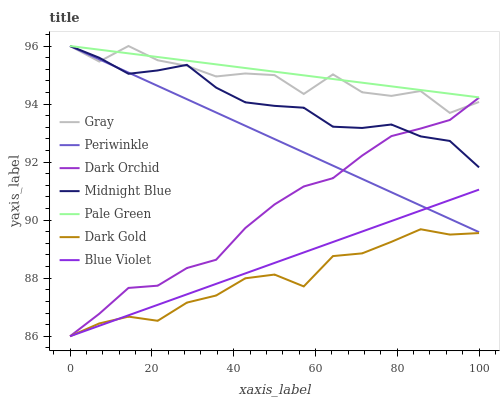Does Dark Gold have the minimum area under the curve?
Answer yes or no. Yes. Does Pale Green have the maximum area under the curve?
Answer yes or no. Yes. Does Midnight Blue have the minimum area under the curve?
Answer yes or no. No. Does Midnight Blue have the maximum area under the curve?
Answer yes or no. No. Is Pale Green the smoothest?
Answer yes or no. Yes. Is Gray the roughest?
Answer yes or no. Yes. Is Midnight Blue the smoothest?
Answer yes or no. No. Is Midnight Blue the roughest?
Answer yes or no. No. Does Dark Gold have the lowest value?
Answer yes or no. Yes. Does Midnight Blue have the lowest value?
Answer yes or no. No. Does Periwinkle have the highest value?
Answer yes or no. Yes. Does Dark Gold have the highest value?
Answer yes or no. No. Is Blue Violet less than Midnight Blue?
Answer yes or no. Yes. Is Pale Green greater than Blue Violet?
Answer yes or no. Yes. Does Dark Orchid intersect Gray?
Answer yes or no. Yes. Is Dark Orchid less than Gray?
Answer yes or no. No. Is Dark Orchid greater than Gray?
Answer yes or no. No. Does Blue Violet intersect Midnight Blue?
Answer yes or no. No. 